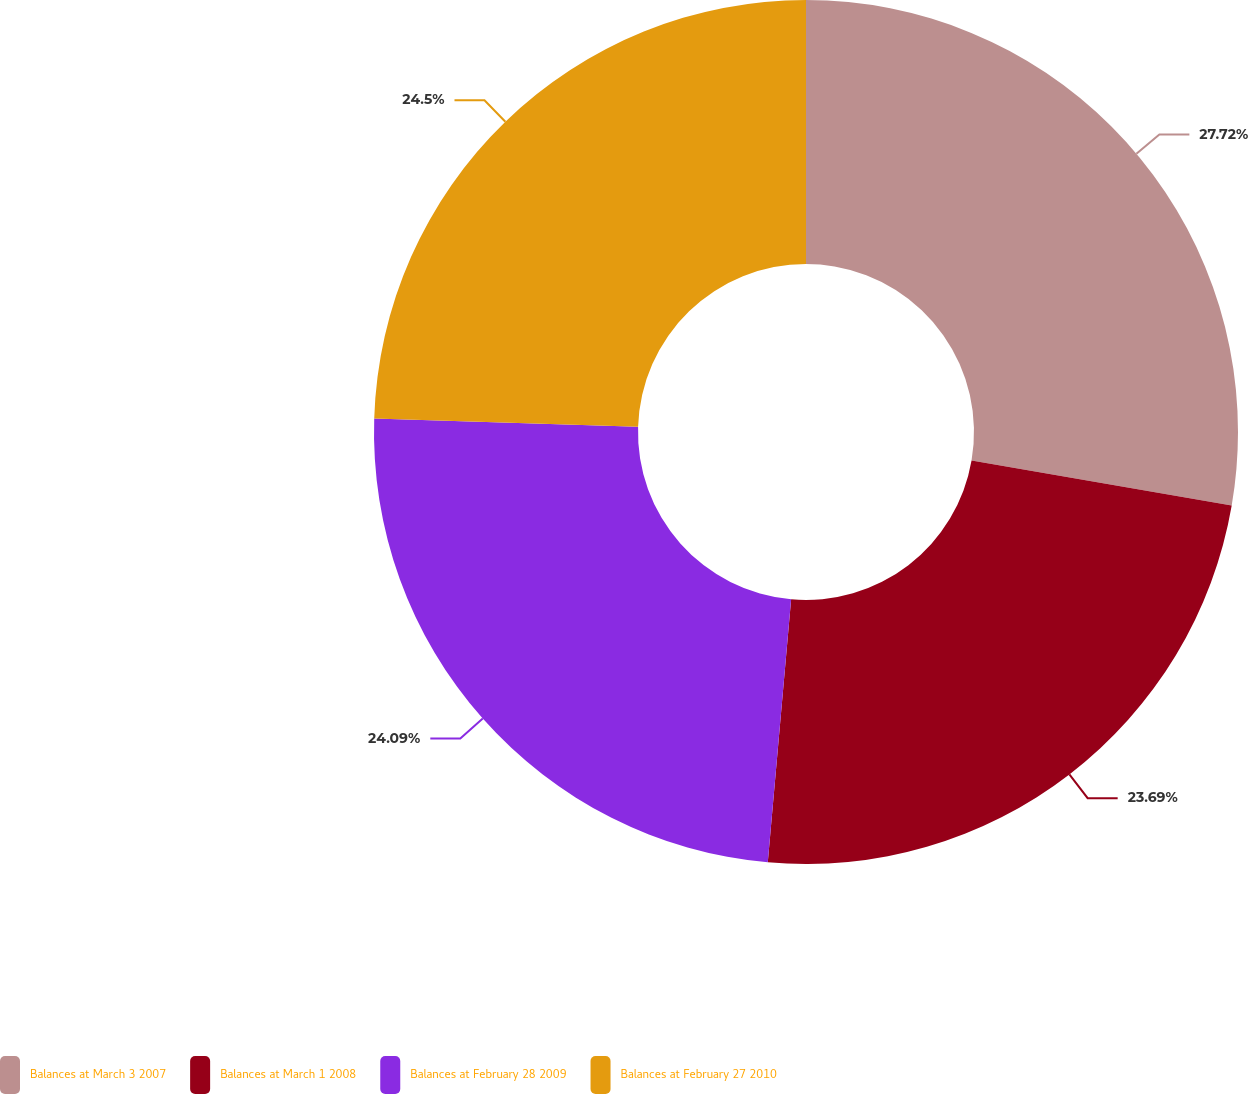Convert chart. <chart><loc_0><loc_0><loc_500><loc_500><pie_chart><fcel>Balances at March 3 2007<fcel>Balances at March 1 2008<fcel>Balances at February 28 2009<fcel>Balances at February 27 2010<nl><fcel>27.72%<fcel>23.69%<fcel>24.09%<fcel>24.5%<nl></chart> 